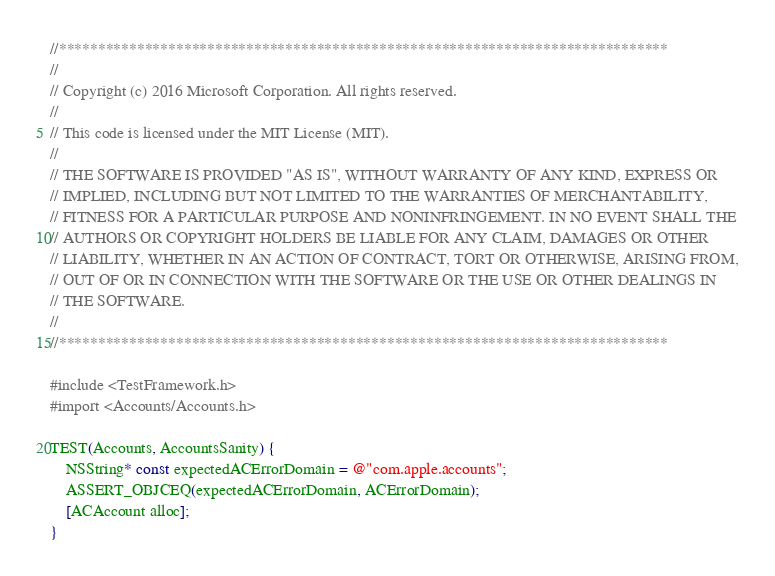<code> <loc_0><loc_0><loc_500><loc_500><_ObjectiveC_>//******************************************************************************
//
// Copyright (c) 2016 Microsoft Corporation. All rights reserved.
//
// This code is licensed under the MIT License (MIT).
//
// THE SOFTWARE IS PROVIDED "AS IS", WITHOUT WARRANTY OF ANY KIND, EXPRESS OR
// IMPLIED, INCLUDING BUT NOT LIMITED TO THE WARRANTIES OF MERCHANTABILITY,
// FITNESS FOR A PARTICULAR PURPOSE AND NONINFRINGEMENT. IN NO EVENT SHALL THE
// AUTHORS OR COPYRIGHT HOLDERS BE LIABLE FOR ANY CLAIM, DAMAGES OR OTHER
// LIABILITY, WHETHER IN AN ACTION OF CONTRACT, TORT OR OTHERWISE, ARISING FROM,
// OUT OF OR IN CONNECTION WITH THE SOFTWARE OR THE USE OR OTHER DEALINGS IN
// THE SOFTWARE.
//
//******************************************************************************

#include <TestFramework.h>
#import <Accounts/Accounts.h>

TEST(Accounts, AccountsSanity) {
    NSString* const expectedACErrorDomain = @"com.apple.accounts";
    ASSERT_OBJCEQ(expectedACErrorDomain, ACErrorDomain);
    [ACAccount alloc];
}</code> 